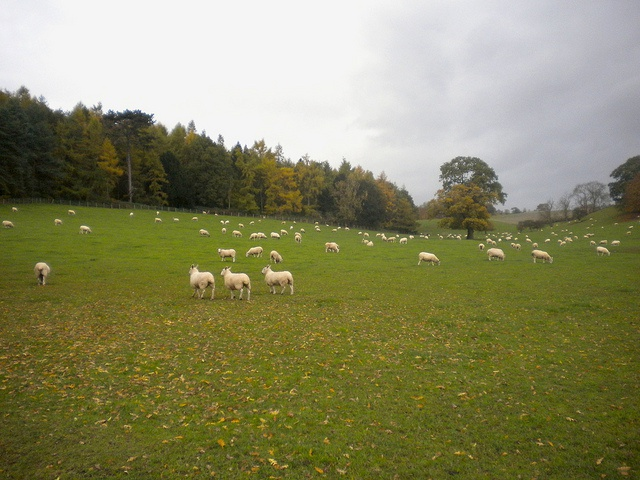Describe the objects in this image and their specific colors. I can see sheep in white and olive tones, sheep in white, tan, and olive tones, sheep in white, tan, and olive tones, sheep in white, tan, and olive tones, and sheep in white, tan, olive, and gray tones in this image. 